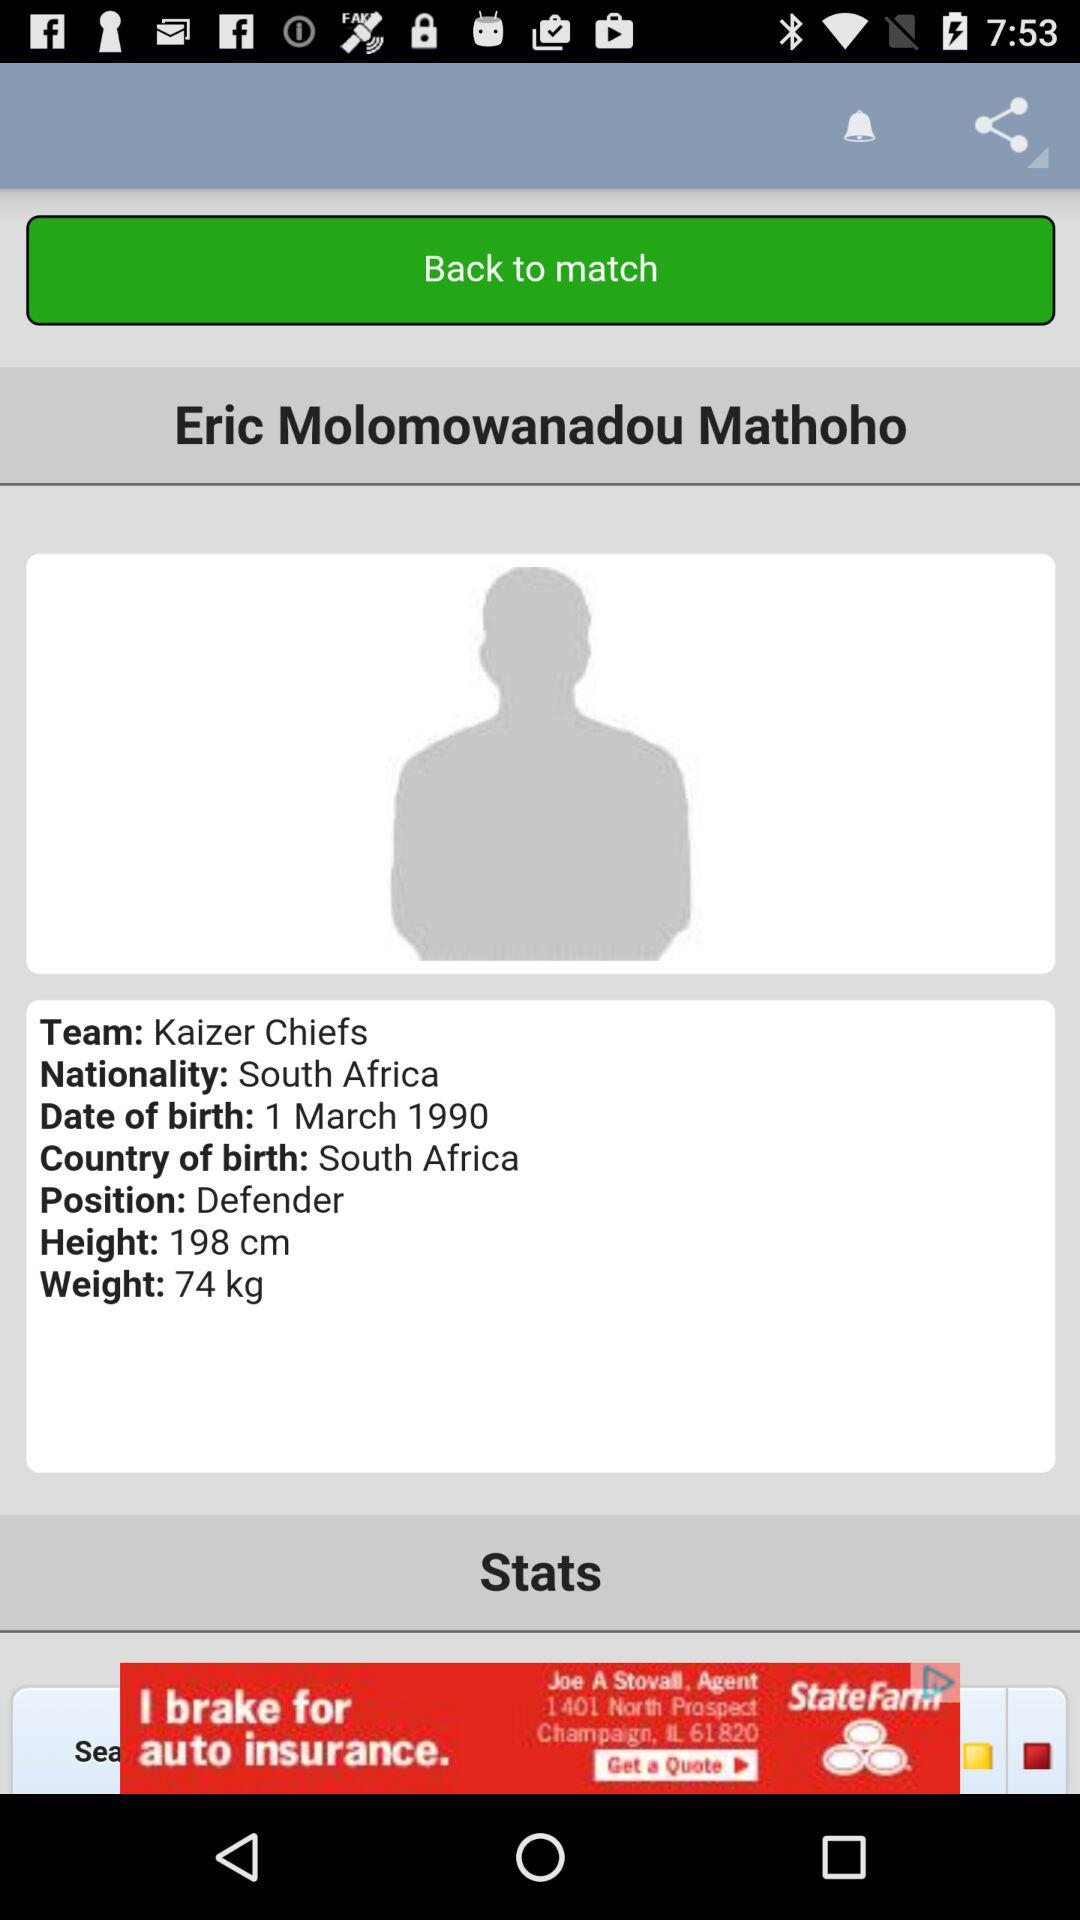What is the team name? The team name is "Kaizer Chiefs". 